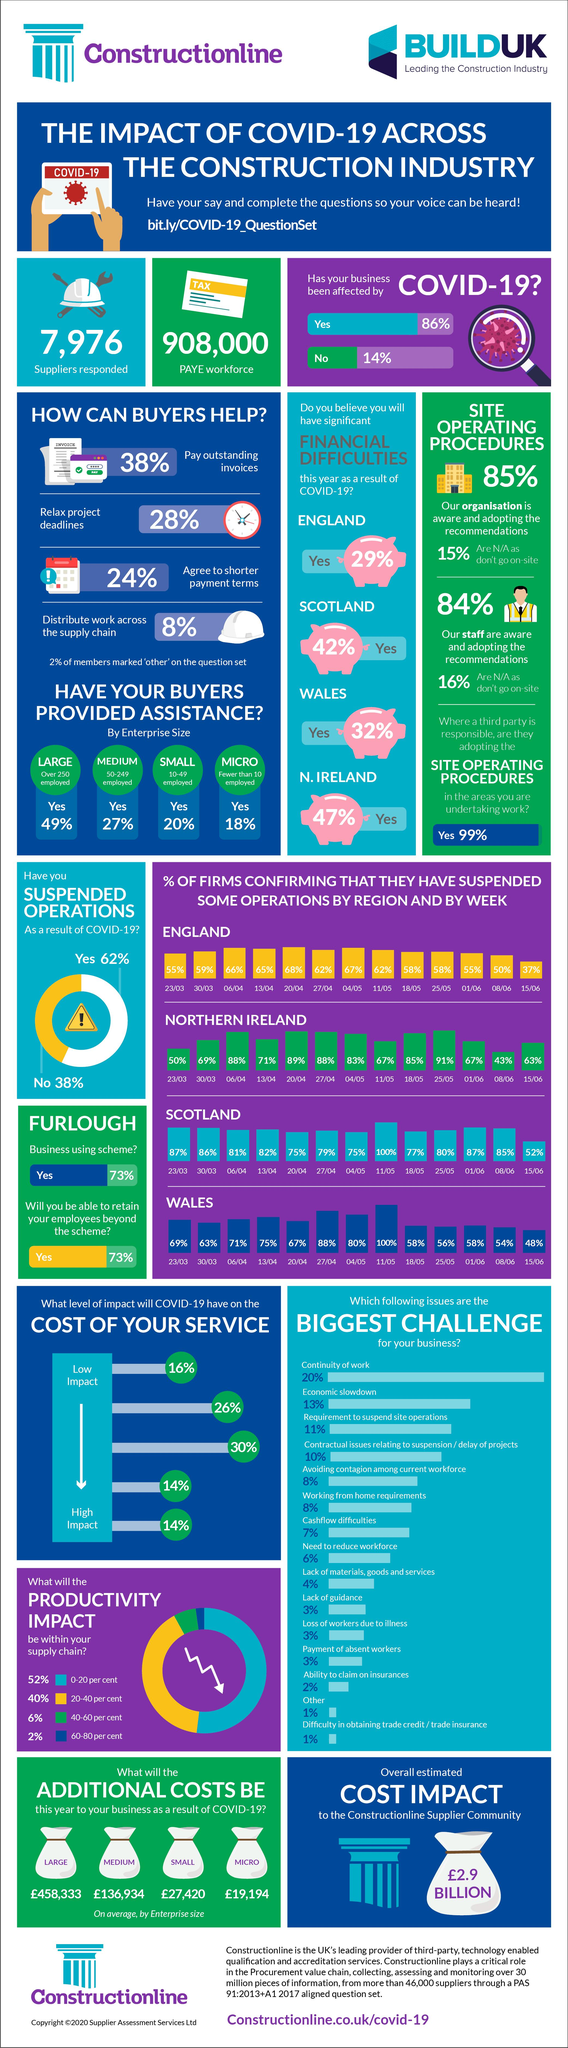Specify some key components in this picture. According to recent data, 13% of firms in the UK believe that the economic slowdown caused by COVID-19 is the biggest challenge facing their business. According to a recent survey, a small percentage of firms in the UK, just 7%, believe that cashflow difficulties are the biggest challenge for their business due to the impact of COVID-19. Eighty-nine percent of firms in Northern Ireland reported that they had temporarily suspended operations on April 20 due to the impact of COVID-19. According to a recent survey, a staggering 82% of firms in Scotland reported having suspended some operations on April 13 due to the severe impact of COVID-19. All firms surveyed in Wales reported that they had temporarily halted some operations on 11/05 due to the effects of COVID-19, resulting in a 100% confirmation rate. 